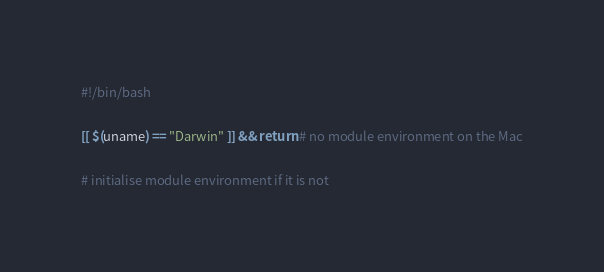Convert code to text. <code><loc_0><loc_0><loc_500><loc_500><_Bash_>#!/bin/bash

[[ $(uname) == "Darwin" ]] && return # no module environment on the Mac

# initialise module environment if it is not</code> 